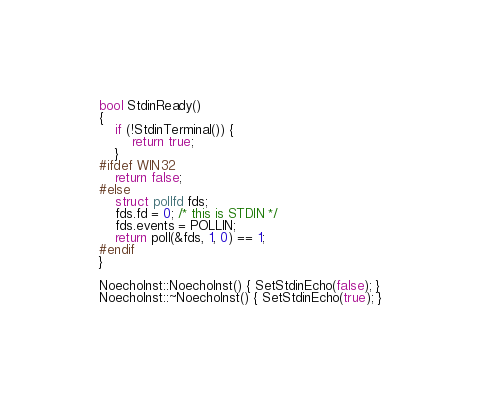Convert code to text. <code><loc_0><loc_0><loc_500><loc_500><_C++_>bool StdinReady()
{
    if (!StdinTerminal()) {
        return true;
    }
#ifdef WIN32
    return false;
#else
    struct pollfd fds;
    fds.fd = 0; /* this is STDIN */
    fds.events = POLLIN;
    return poll(&fds, 1, 0) == 1;
#endif
}

NoechoInst::NoechoInst() { SetStdinEcho(false); }
NoechoInst::~NoechoInst() { SetStdinEcho(true); }
</code> 